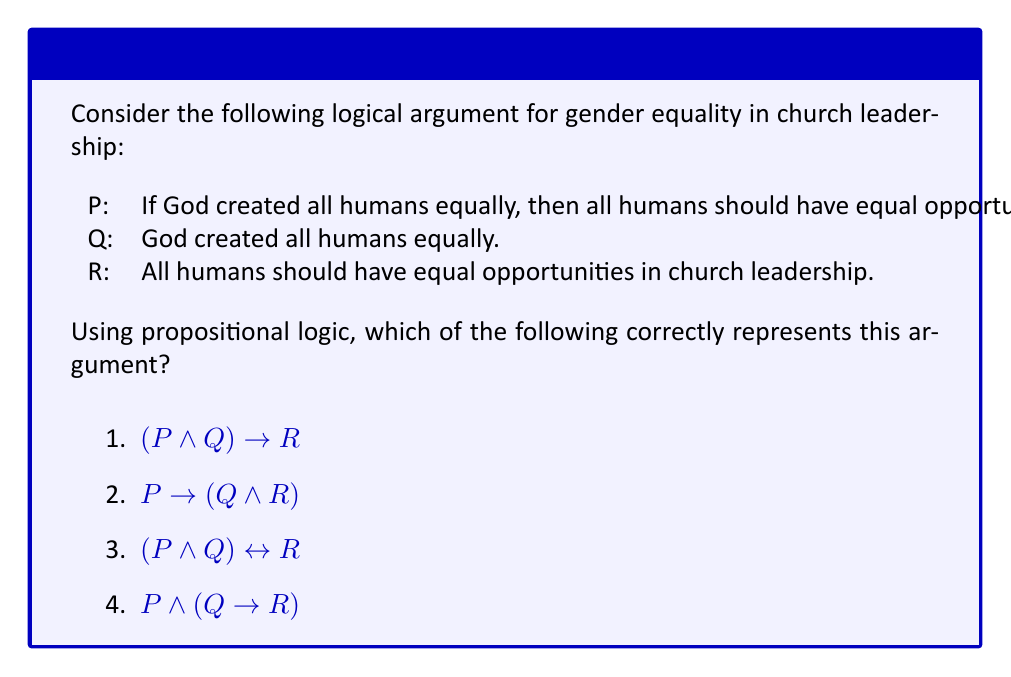Provide a solution to this math problem. Let's analyze this argument step-by-step using propositional logic:

1) First, we need to identify the logical structure of the argument:
   - P is the conditional statement: "If God created all humans equally, then all humans should have equal opportunities in church leadership."
   - Q is the premise: "God created all humans equally."
   - R is the conclusion: "All humans should have equal opportunities in church leadership."

2) The argument structure is:
   - If P is true and Q is true, then R must be true.
   - This is known as Modus Ponens in propositional logic.

3) In symbolic form, Modus Ponens is represented as:
   $$(P \land Q) \rightarrow R$$

4) Let's evaluate each option:
   1) $$(P \land Q) \rightarrow R$$ : This correctly represents the argument structure.
   2) $$P \rightarrow (Q \land R)$$ : This implies that P leads to both Q and R, which is not the given argument.
   3) $$(P \land Q) \leftrightarrow R$$ : This suggests that R is both necessary and sufficient for P and Q, which is stronger than the given argument.
   4) $$P \land (Q \rightarrow R)$$ : This separates P from the implication, which doesn't match the argument structure.

5) Therefore, option 1 is the correct representation of the argument.
Answer: 1) $$(P \land Q) \rightarrow R$$ 